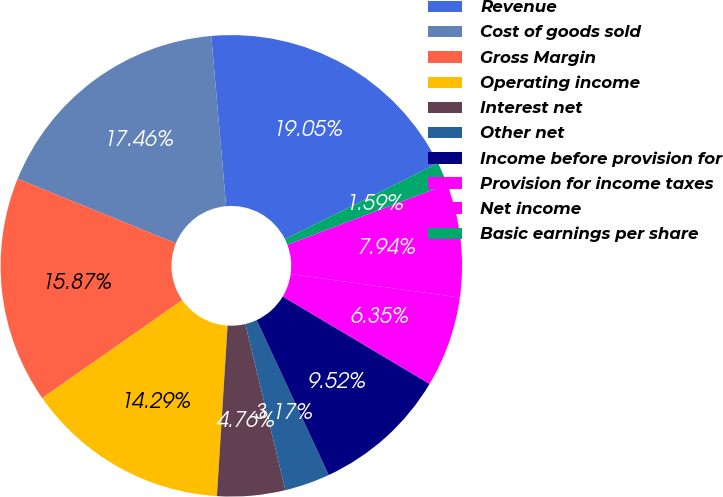Convert chart to OTSL. <chart><loc_0><loc_0><loc_500><loc_500><pie_chart><fcel>Revenue<fcel>Cost of goods sold<fcel>Gross Margin<fcel>Operating income<fcel>Interest net<fcel>Other net<fcel>Income before provision for<fcel>Provision for income taxes<fcel>Net income<fcel>Basic earnings per share<nl><fcel>19.05%<fcel>17.46%<fcel>15.87%<fcel>14.29%<fcel>4.76%<fcel>3.17%<fcel>9.52%<fcel>6.35%<fcel>7.94%<fcel>1.59%<nl></chart> 